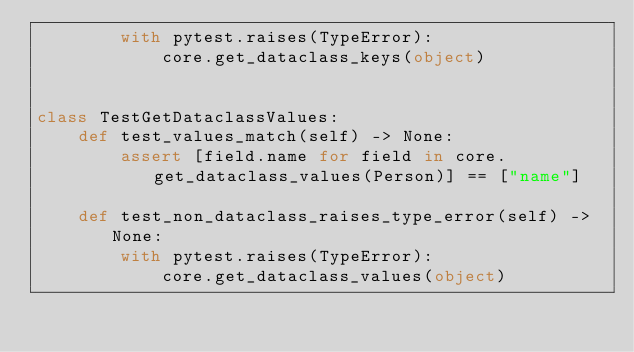Convert code to text. <code><loc_0><loc_0><loc_500><loc_500><_Python_>        with pytest.raises(TypeError):
            core.get_dataclass_keys(object)


class TestGetDataclassValues:
    def test_values_match(self) -> None:
        assert [field.name for field in core.get_dataclass_values(Person)] == ["name"]

    def test_non_dataclass_raises_type_error(self) -> None:
        with pytest.raises(TypeError):
            core.get_dataclass_values(object)
</code> 